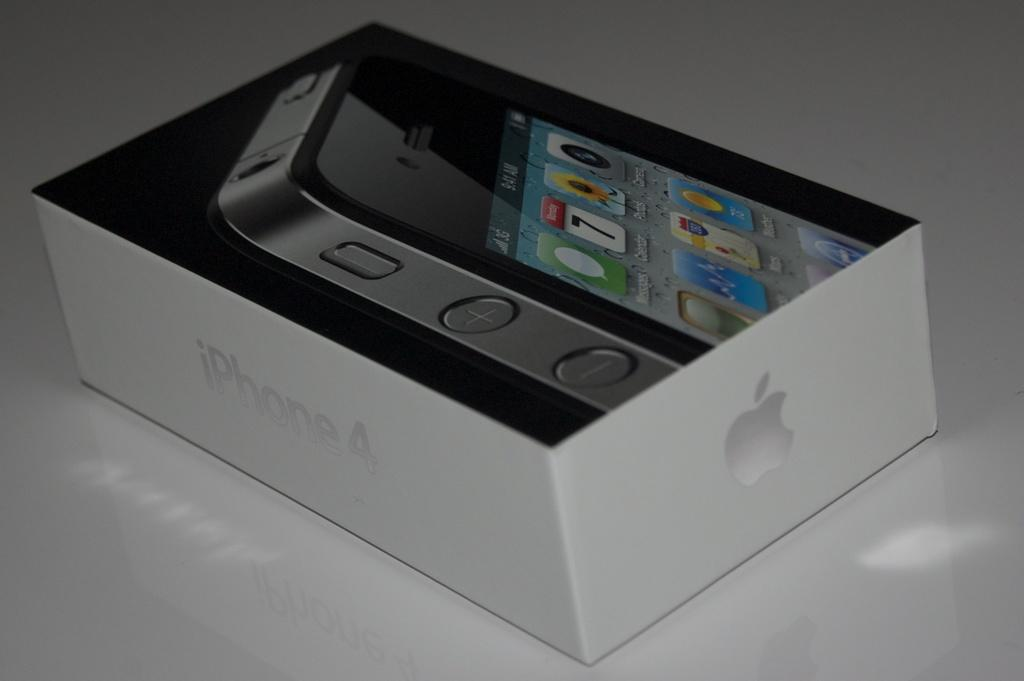<image>
Render a clear and concise summary of the photo. Box that has a picture of a phone on top and the words "iPhone4" on the side. 